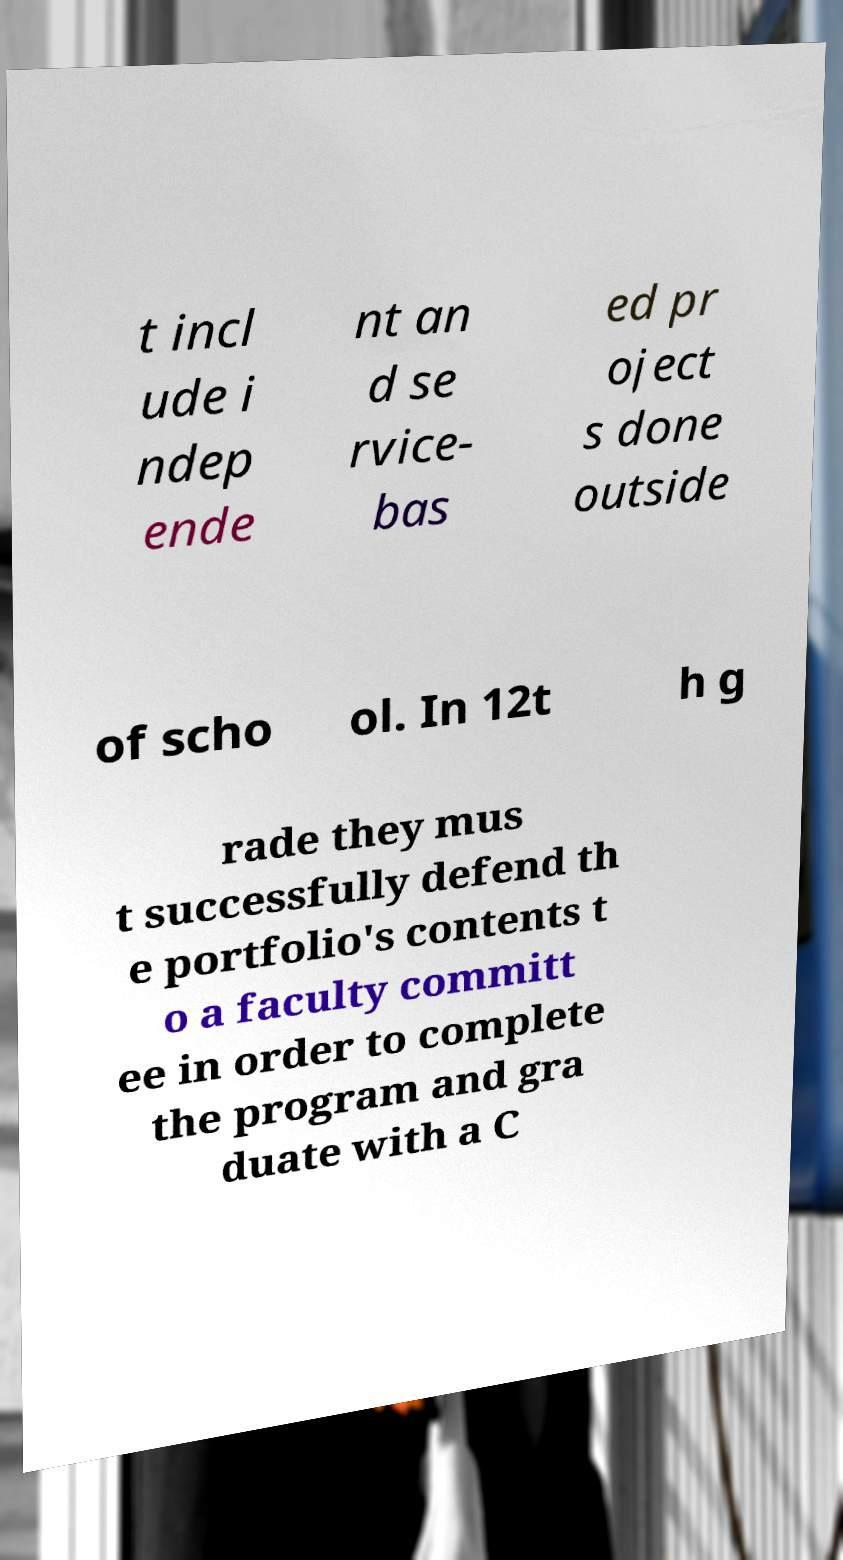Could you assist in decoding the text presented in this image and type it out clearly? t incl ude i ndep ende nt an d se rvice- bas ed pr oject s done outside of scho ol. In 12t h g rade they mus t successfully defend th e portfolio's contents t o a faculty committ ee in order to complete the program and gra duate with a C 